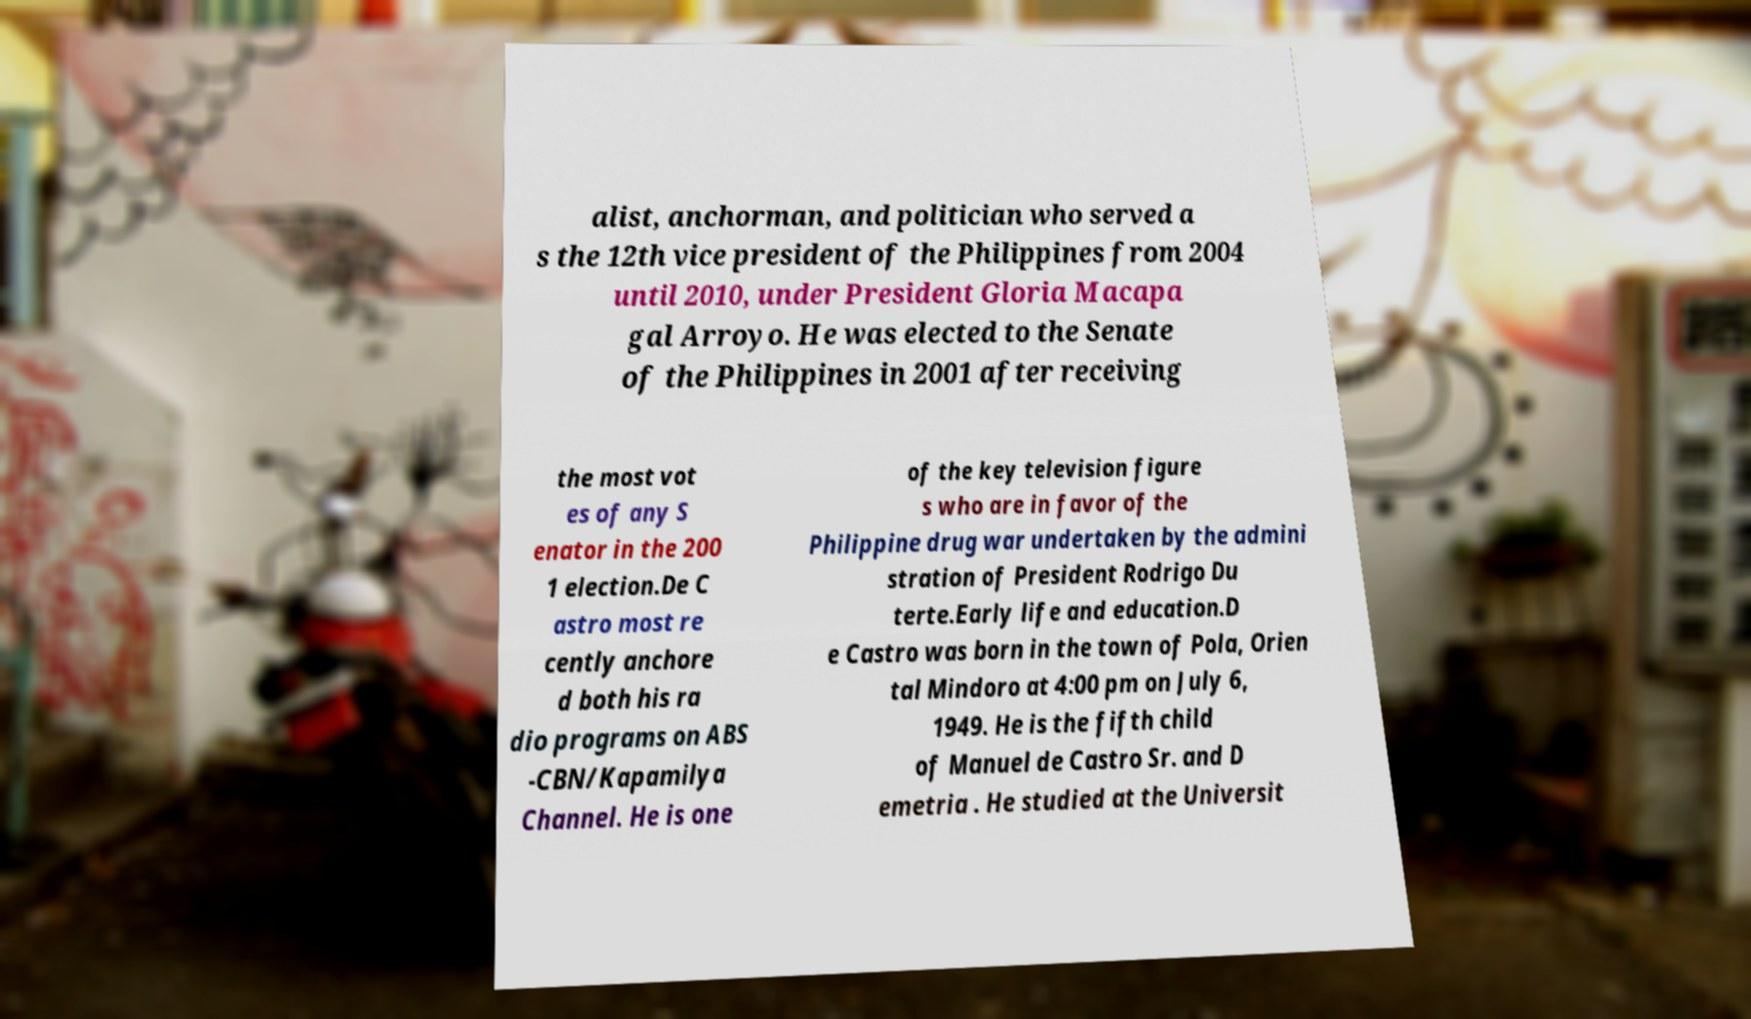Could you assist in decoding the text presented in this image and type it out clearly? alist, anchorman, and politician who served a s the 12th vice president of the Philippines from 2004 until 2010, under President Gloria Macapa gal Arroyo. He was elected to the Senate of the Philippines in 2001 after receiving the most vot es of any S enator in the 200 1 election.De C astro most re cently anchore d both his ra dio programs on ABS -CBN/Kapamilya Channel. He is one of the key television figure s who are in favor of the Philippine drug war undertaken by the admini stration of President Rodrigo Du terte.Early life and education.D e Castro was born in the town of Pola, Orien tal Mindoro at 4:00 pm on July 6, 1949. He is the fifth child of Manuel de Castro Sr. and D emetria . He studied at the Universit 